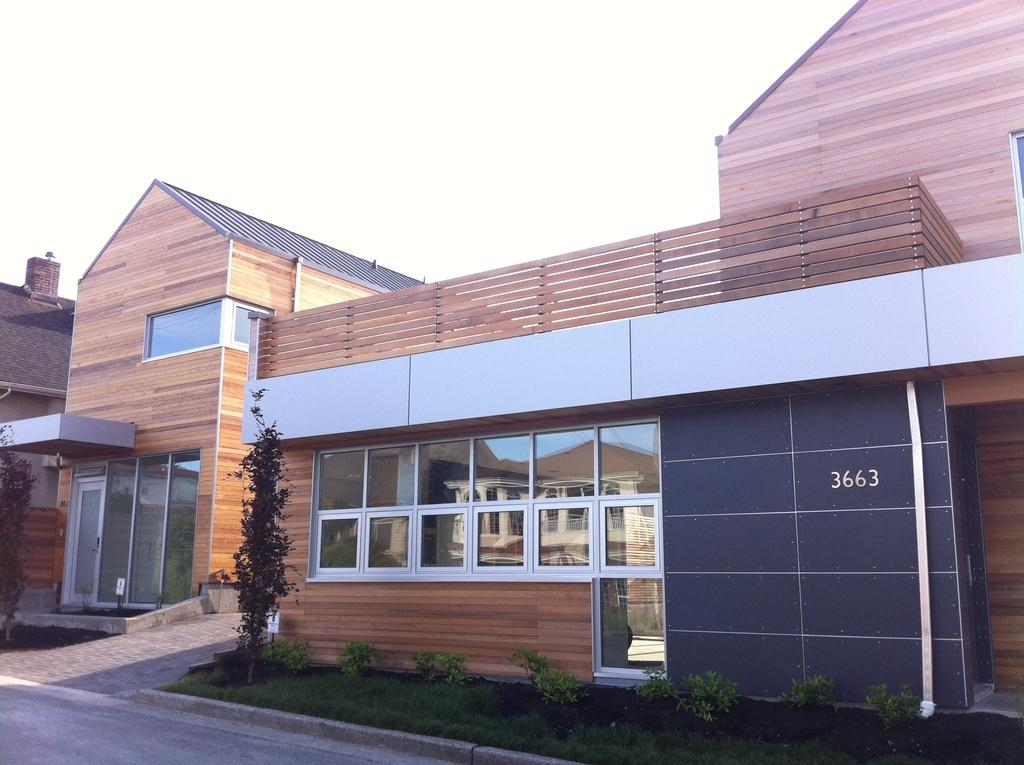What type of building is in the image? There is a wooden building in the image. What feature of the building is mentioned in the facts? The building has many windows. What can be seen in front of the building? There are plants and grass in front of the building. What type of leather is used to make the chess pieces in the image? There is no mention of chess or leather in the image, so it is not possible to answer that question. 